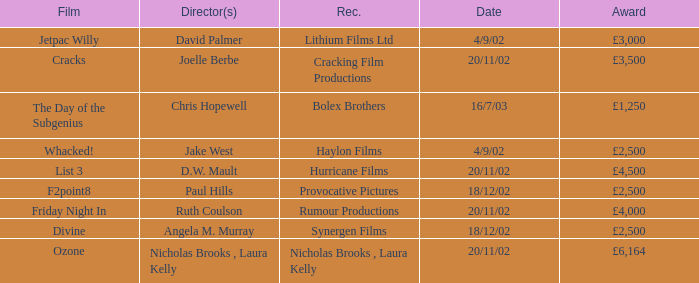What award did the film Ozone win? £6,164. 